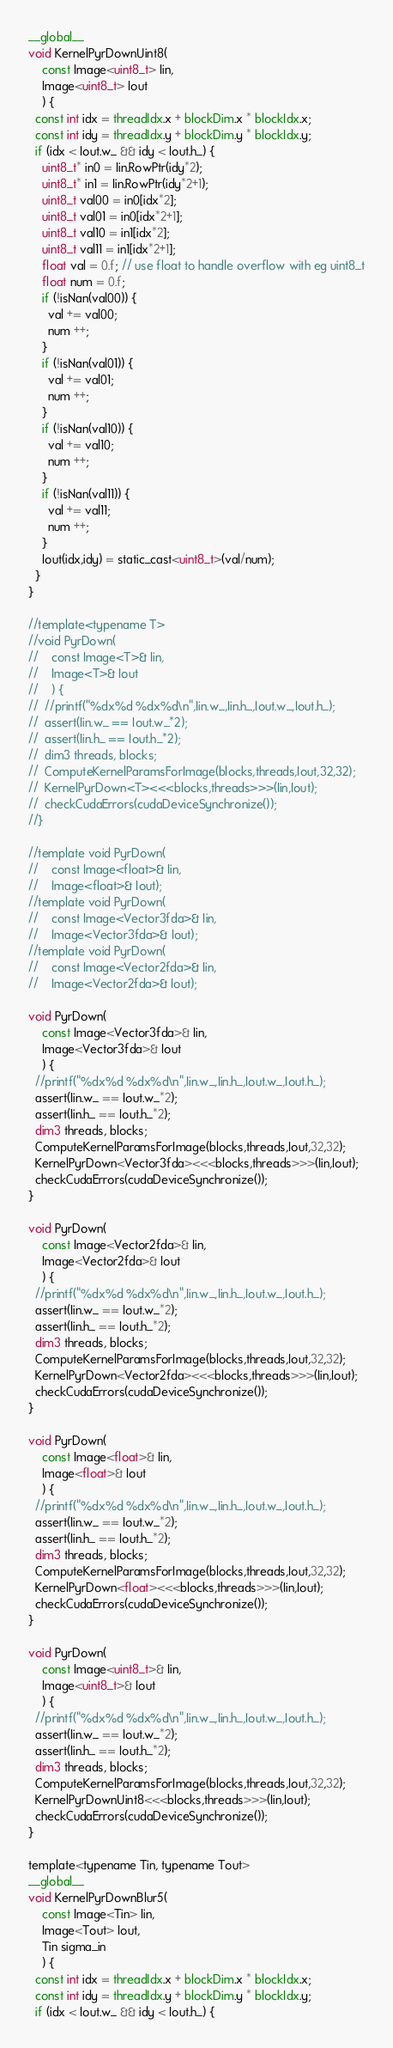<code> <loc_0><loc_0><loc_500><loc_500><_Cuda_>__global__
void KernelPyrDownUint8(
    const Image<uint8_t> Iin,
    Image<uint8_t> Iout
    ) {
  const int idx = threadIdx.x + blockDim.x * blockIdx.x;
  const int idy = threadIdx.y + blockDim.y * blockIdx.y;
  if (idx < Iout.w_ && idy < Iout.h_) {
    uint8_t* in0 = Iin.RowPtr(idy*2);
    uint8_t* in1 = Iin.RowPtr(idy*2+1);
    uint8_t val00 = in0[idx*2];
    uint8_t val01 = in0[idx*2+1];
    uint8_t val10 = in1[idx*2];
    uint8_t val11 = in1[idx*2+1];
    float val = 0.f; // use float to handle overflow with eg uint8_t
    float num = 0.f;
    if (!isNan(val00)) {
      val += val00;
      num ++;
    }
    if (!isNan(val01)) {
      val += val01;
      num ++;
    }
    if (!isNan(val10)) {
      val += val10;
      num ++;
    }
    if (!isNan(val11)) {
      val += val11;
      num ++;
    }
    Iout(idx,idy) = static_cast<uint8_t>(val/num);
  }
}

//template<typename T>
//void PyrDown(
//    const Image<T>& Iin,
//    Image<T>& Iout
//    ) {
//  //printf("%dx%d %dx%d\n",Iin.w_,Iin.h_,Iout.w_,Iout.h_);
//  assert(Iin.w_ == Iout.w_*2);
//  assert(Iin.h_ == Iout.h_*2);
//  dim3 threads, blocks;
//  ComputeKernelParamsForImage(blocks,threads,Iout,32,32);
//  KernelPyrDown<T><<<blocks,threads>>>(Iin,Iout);
//  checkCudaErrors(cudaDeviceSynchronize());
//}

//template void PyrDown(
//    const Image<float>& Iin,
//    Image<float>& Iout);
//template void PyrDown(
//    const Image<Vector3fda>& Iin,
//    Image<Vector3fda>& Iout);
//template void PyrDown(
//    const Image<Vector2fda>& Iin,
//    Image<Vector2fda>& Iout);

void PyrDown(
    const Image<Vector3fda>& Iin,
    Image<Vector3fda>& Iout
    ) {
  //printf("%dx%d %dx%d\n",Iin.w_,Iin.h_,Iout.w_,Iout.h_);
  assert(Iin.w_ == Iout.w_*2);
  assert(Iin.h_ == Iout.h_*2);
  dim3 threads, blocks;
  ComputeKernelParamsForImage(blocks,threads,Iout,32,32);
  KernelPyrDown<Vector3fda><<<blocks,threads>>>(Iin,Iout);
  checkCudaErrors(cudaDeviceSynchronize());
}

void PyrDown(
    const Image<Vector2fda>& Iin,
    Image<Vector2fda>& Iout
    ) {
  //printf("%dx%d %dx%d\n",Iin.w_,Iin.h_,Iout.w_,Iout.h_);
  assert(Iin.w_ == Iout.w_*2);
  assert(Iin.h_ == Iout.h_*2);
  dim3 threads, blocks;
  ComputeKernelParamsForImage(blocks,threads,Iout,32,32);
  KernelPyrDown<Vector2fda><<<blocks,threads>>>(Iin,Iout);
  checkCudaErrors(cudaDeviceSynchronize());
}

void PyrDown(
    const Image<float>& Iin,
    Image<float>& Iout
    ) {
  //printf("%dx%d %dx%d\n",Iin.w_,Iin.h_,Iout.w_,Iout.h_);
  assert(Iin.w_ == Iout.w_*2);
  assert(Iin.h_ == Iout.h_*2);
  dim3 threads, blocks;
  ComputeKernelParamsForImage(blocks,threads,Iout,32,32);
  KernelPyrDown<float><<<blocks,threads>>>(Iin,Iout);
  checkCudaErrors(cudaDeviceSynchronize());
}

void PyrDown(
    const Image<uint8_t>& Iin,
    Image<uint8_t>& Iout
    ) {
  //printf("%dx%d %dx%d\n",Iin.w_,Iin.h_,Iout.w_,Iout.h_);
  assert(Iin.w_ == Iout.w_*2);
  assert(Iin.h_ == Iout.h_*2);
  dim3 threads, blocks;
  ComputeKernelParamsForImage(blocks,threads,Iout,32,32);
  KernelPyrDownUint8<<<blocks,threads>>>(Iin,Iout);
  checkCudaErrors(cudaDeviceSynchronize());
}

template<typename Tin, typename Tout>
__global__
void KernelPyrDownBlur5(
    const Image<Tin> Iin,
    Image<Tout> Iout,
    Tin sigma_in
    ) {
  const int idx = threadIdx.x + blockDim.x * blockIdx.x;
  const int idy = threadIdx.y + blockDim.y * blockIdx.y;
  if (idx < Iout.w_ && idy < Iout.h_) {</code> 